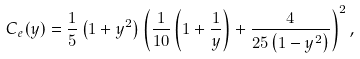<formula> <loc_0><loc_0><loc_500><loc_500>C _ { e } ( y ) = \frac { 1 } { 5 } \left ( 1 + y ^ { 2 } \right ) \left ( \frac { 1 } { 1 0 } \left ( 1 + \frac { 1 } { y } \right ) + \frac { 4 } { 2 5 \left ( 1 - y ^ { 2 } \right ) } \right ) ^ { 2 } ,</formula> 